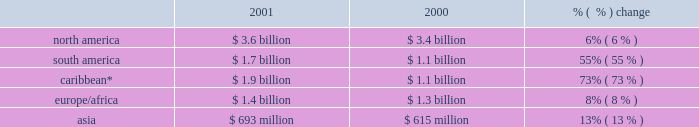Increase .
In north america , contract generation segment revenues increased $ 46 million .
In the caribbean ( which includes venezuela and colombia ) , contract generation segment revenues increased $ 11 million , and this was due to a full year of operations at merida iii offset by a lower capacity factor at los mina .
Competitive supply revenues increased $ 300 million or 13% ( 13 % ) to $ 2.7 billion in 2001 from $ 2.4 billion in 2000 .
Excluding businesses acquired or that commenced commercial operations in 2001 or 2000 , competitive supply revenues increased 3% ( 3 % ) to $ 2.4 billion in 2001 .
The most significant increases occurred within north america and the caribbean .
Slight increases were recorded within south america and asia .
Europe/africa reported a slight decrease due to lower pool prices in the u.k .
Offset by the start of commercial operations at fifoots and the acquisition of ottana .
In north america , competitive supply segment revenues increased $ 184 million due primarily to an expanded customer base at new energy as well as increased operations at placerita .
These increases in north america were offset by lower market prices at our new york businesses .
In the caribbean , competitive supply segment revenues increased $ 123 million due primarily to the acquisition of chivor .
Large utility revenues increased $ 300 million , or 14% ( 14 % ) to $ 2.4 billion in 2001 from $ 2.1 billion in 2000 , principally resulting from the addition of revenues attributable to businesses acquired during 2001 or 2000 .
Excluding businesses acquired in 2001 and 2000 , large utility revenues increased 1% ( 1 % ) to $ 1.6 billion in 2001 .
The majority of the increase occurred within the caribbean , and there was a slight increase in north america .
In the caribbean , revenues increased $ 312 million due to a full year of revenues from edc , which was acquired in june 2000 .
Growth distribution revenues increased $ 400 million , or 31% ( 31 % ) to $ 1.7 billion in 2001 from $ 1.3 billion in 2000 .
Excluding businesses acquired in 2001 or 2000 , growth distribution revenues increased 20% ( 20 % ) to $ 1.3 billion in 2001 .
Revenues increased most significantly in the caribbean and to a lesser extent in south america and europe/africa .
Revenues decreased slightly in asia .
In the caribbean , growth distribution segment revenues increased $ 296 million due primarily to a full year of operations at caess , which was acquired in 2000 and improved operations at ede este .
In south america , growth distribution segment revenues increased $ 89 million due to the significant revenues at sul from our settlement with the brazilian government offset by declines in revenues at our argentine distribution businesses .
The settlement with the brazilian government confirmed the sales price that sul would receive from its sales into the southeast market ( where rationing occurred ) under its itaipu contract .
In europe/africa , growth distribution segment revenues increased $ 59 million from the acquisition of sonel .
In asia , growth distribution segment revenues decreased $ 33 million mainly due to the change in the way in which we are accounting for our investment in cesco .
Cesco was previously consolidated but was changed to equity method during 2001 when the company was removed from management and the board of directors .
This decline was partially offset by the increase in revenues from the distribution businesses that we acquired in the ukraine .
Aes is a global power company which operates in 29 countries around the world .
The breakdown of aes 2019s revenues for the years ended december 31 , 2001 and 2000 , based on the geographic region in which they were earned , is set forth below .
A more detailed breakdown by country can be found in note 16 of the consolidated financial statements. .
* includes venezuela and colombia. .
Total americas segment revenues were how much ( in billions ) in 2001? 
Computations: (3.6 + 1.7)
Answer: 5.3. 